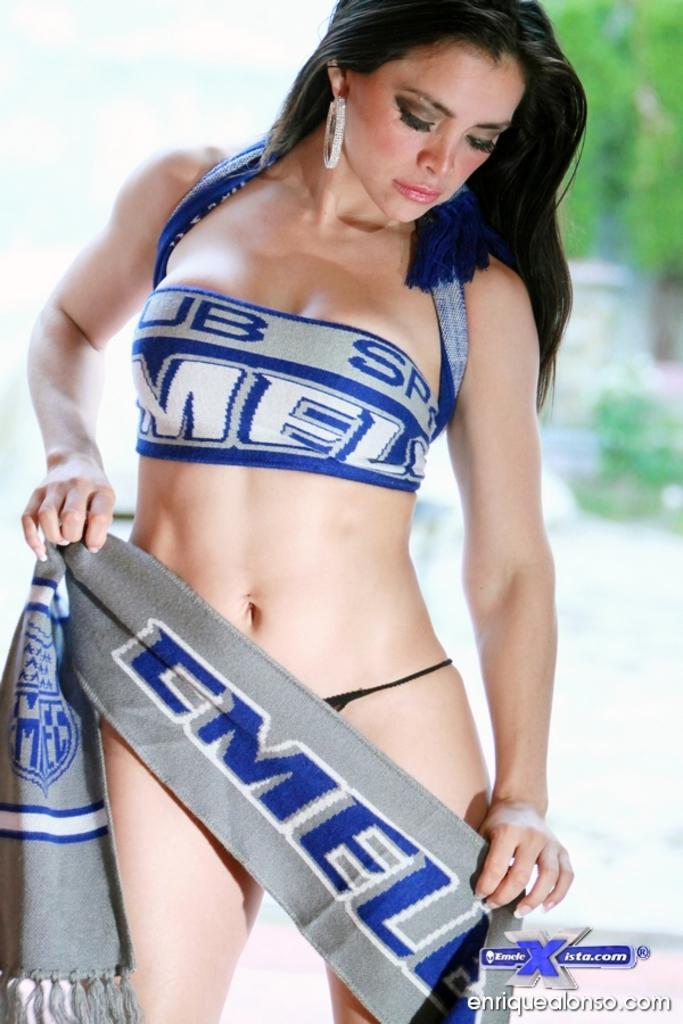Can you describe this image briefly? In this image I see a woman who is wearing a bikini and I see that she is holding a cloth in her hands which is of grey, white and blue in color and I see a word written over here and I see the watermark over here and it is blurred in the background. 